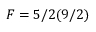<formula> <loc_0><loc_0><loc_500><loc_500>F = 5 / 2 ( 9 / 2 )</formula> 